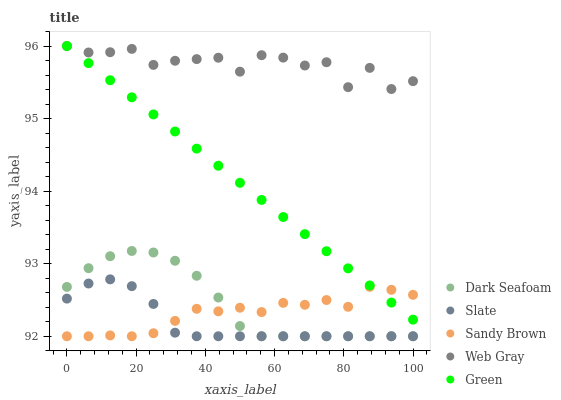Does Slate have the minimum area under the curve?
Answer yes or no. Yes. Does Web Gray have the maximum area under the curve?
Answer yes or no. Yes. Does Dark Seafoam have the minimum area under the curve?
Answer yes or no. No. Does Dark Seafoam have the maximum area under the curve?
Answer yes or no. No. Is Green the smoothest?
Answer yes or no. Yes. Is Web Gray the roughest?
Answer yes or no. Yes. Is Dark Seafoam the smoothest?
Answer yes or no. No. Is Dark Seafoam the roughest?
Answer yes or no. No. Does Dark Seafoam have the lowest value?
Answer yes or no. Yes. Does Web Gray have the lowest value?
Answer yes or no. No. Does Web Gray have the highest value?
Answer yes or no. Yes. Does Dark Seafoam have the highest value?
Answer yes or no. No. Is Dark Seafoam less than Green?
Answer yes or no. Yes. Is Web Gray greater than Dark Seafoam?
Answer yes or no. Yes. Does Sandy Brown intersect Slate?
Answer yes or no. Yes. Is Sandy Brown less than Slate?
Answer yes or no. No. Is Sandy Brown greater than Slate?
Answer yes or no. No. Does Dark Seafoam intersect Green?
Answer yes or no. No. 